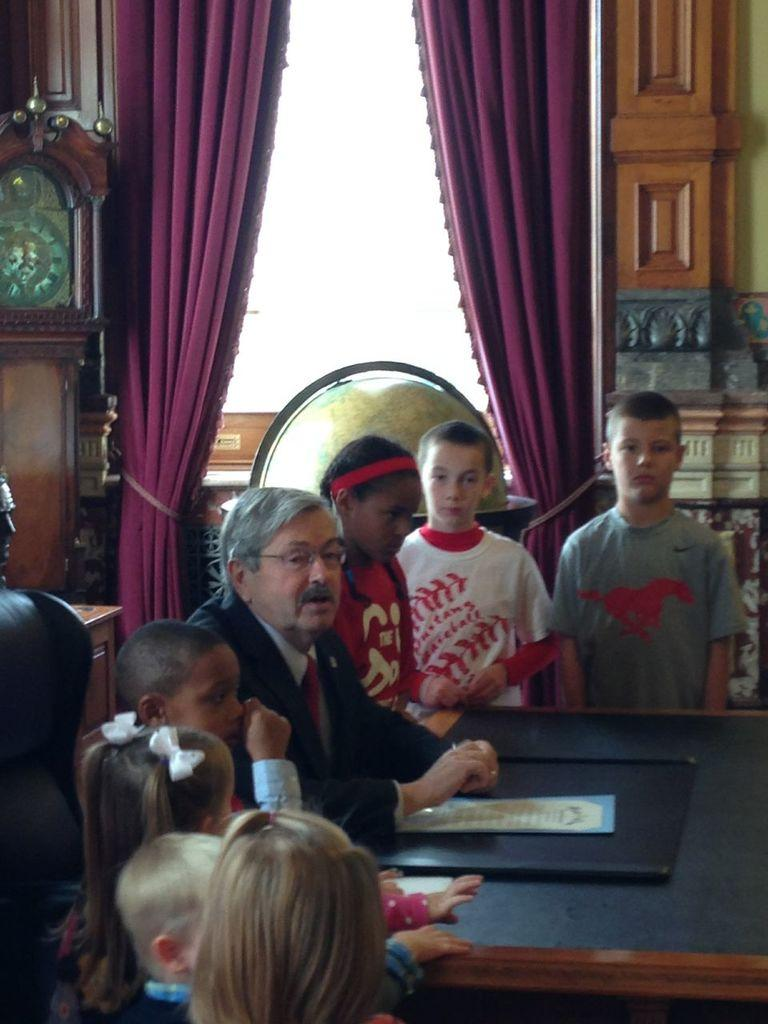What are the persons in the image doing? The persons in the image are sitting and standing on the floor. What is placed in front of the persons? There is a table placed in front of the persons. What can be seen in the background of the image? In the background of the image, there are curtains, doors, and the sky. What type of earth can be seen in the image? There is no earth visible in the image; it is an indoor setting with a floor, table, and background elements. 